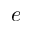<formula> <loc_0><loc_0><loc_500><loc_500>e</formula> 